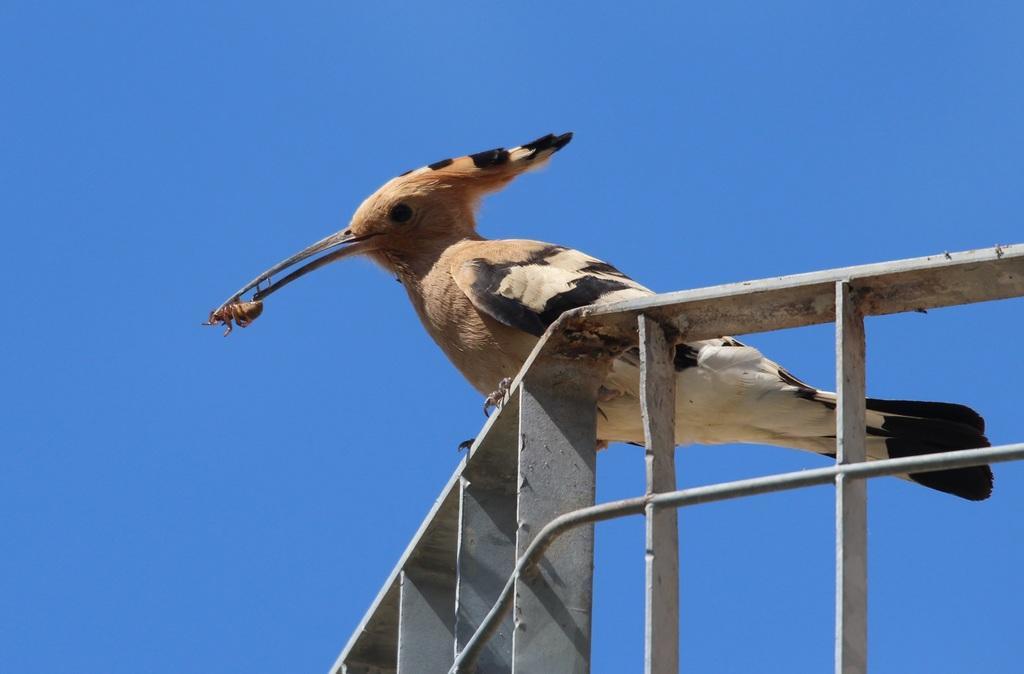How would you summarize this image in a sentence or two? In this image, I can see a bird on an iron grille and holding an insect. In the background, there is the sky. 